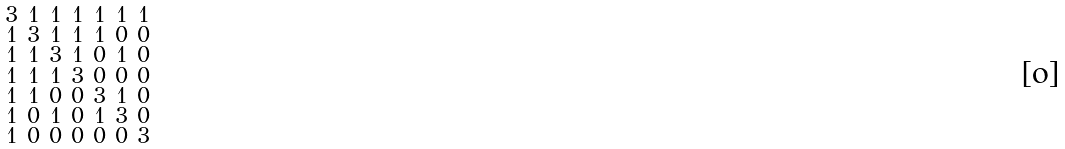Convert formula to latex. <formula><loc_0><loc_0><loc_500><loc_500>\begin{smallmatrix} 3 & 1 & 1 & 1 & 1 & 1 & 1 \\ 1 & 3 & 1 & 1 & 1 & 0 & 0 \\ 1 & 1 & 3 & 1 & 0 & 1 & 0 \\ 1 & 1 & 1 & 3 & 0 & 0 & 0 \\ 1 & 1 & 0 & 0 & 3 & 1 & 0 \\ 1 & 0 & 1 & 0 & 1 & 3 & 0 \\ 1 & 0 & 0 & 0 & 0 & 0 & 3 \end{smallmatrix}</formula> 